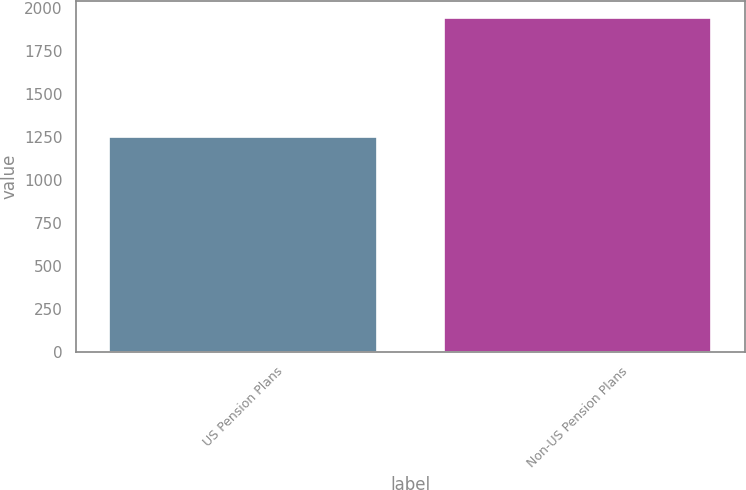Convert chart. <chart><loc_0><loc_0><loc_500><loc_500><bar_chart><fcel>US Pension Plans<fcel>Non-US Pension Plans<nl><fcel>1249<fcel>1941<nl></chart> 